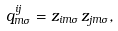<formula> <loc_0><loc_0><loc_500><loc_500>q _ { m \sigma } ^ { i j } = z _ { i m \sigma } \, z _ { j m \sigma } ,</formula> 